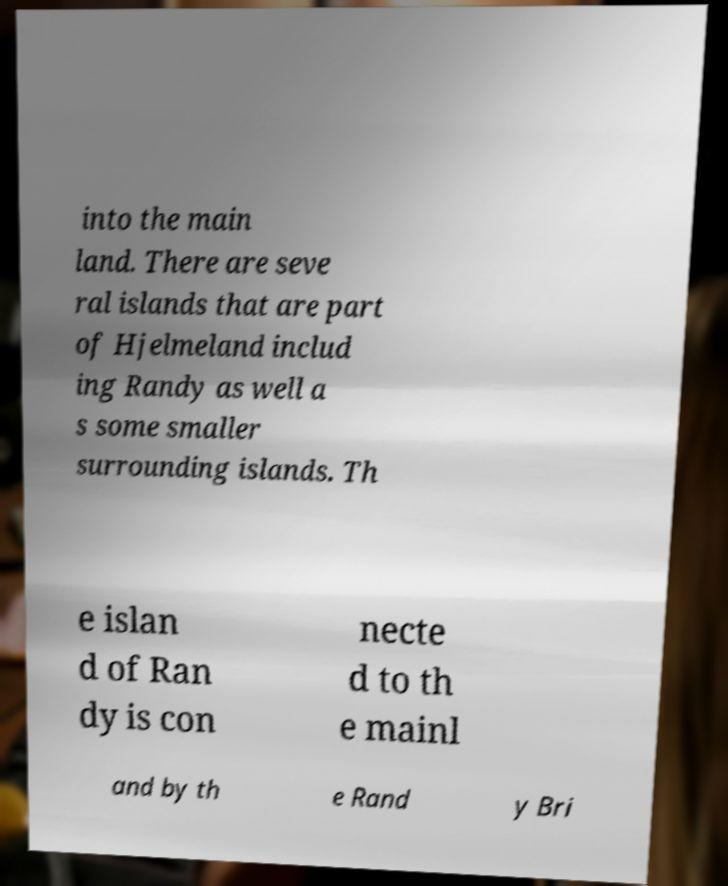Please read and relay the text visible in this image. What does it say? into the main land. There are seve ral islands that are part of Hjelmeland includ ing Randy as well a s some smaller surrounding islands. Th e islan d of Ran dy is con necte d to th e mainl and by th e Rand y Bri 